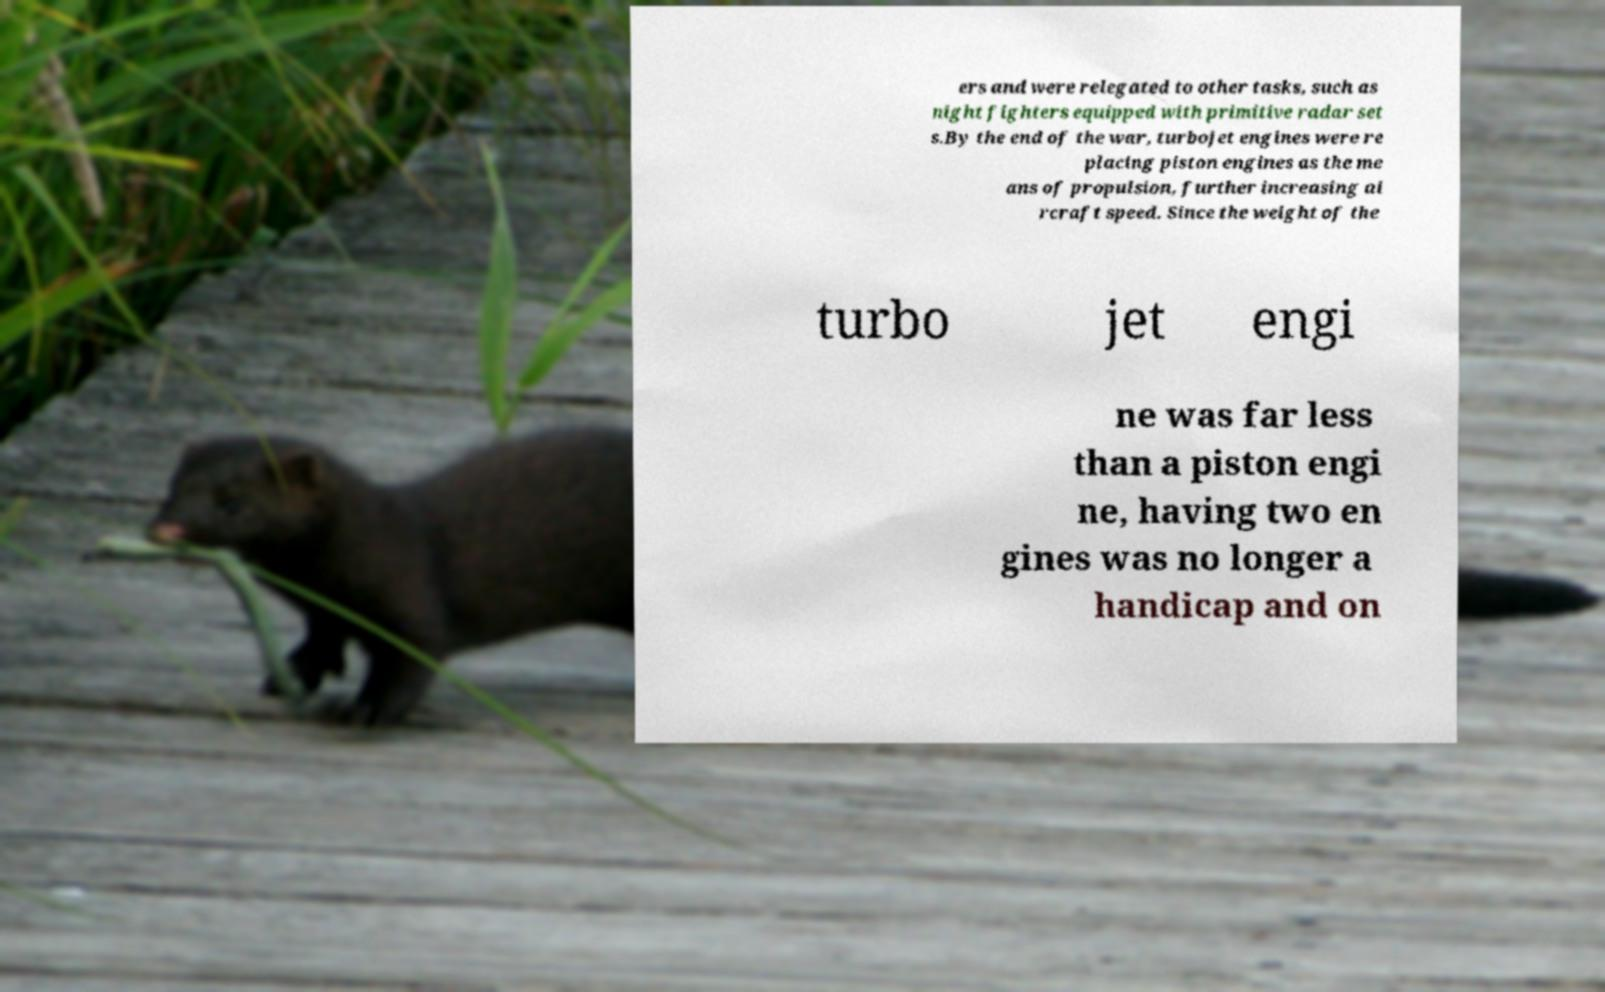Can you read and provide the text displayed in the image?This photo seems to have some interesting text. Can you extract and type it out for me? ers and were relegated to other tasks, such as night fighters equipped with primitive radar set s.By the end of the war, turbojet engines were re placing piston engines as the me ans of propulsion, further increasing ai rcraft speed. Since the weight of the turbo jet engi ne was far less than a piston engi ne, having two en gines was no longer a handicap and on 